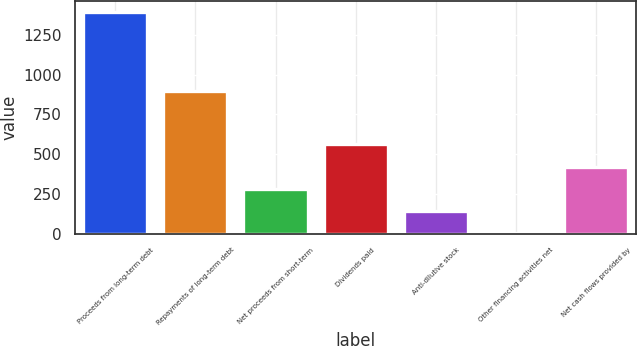Convert chart to OTSL. <chart><loc_0><loc_0><loc_500><loc_500><bar_chart><fcel>Proceeds from long-term debt<fcel>Repayments of long-term debt<fcel>Net proceeds from short-term<fcel>Dividends paid<fcel>Anti-dilutive stock<fcel>Other financing activities net<fcel>Net cash flows provided by<nl><fcel>1395<fcel>896<fcel>282.2<fcel>560.4<fcel>143.1<fcel>4<fcel>421.3<nl></chart> 